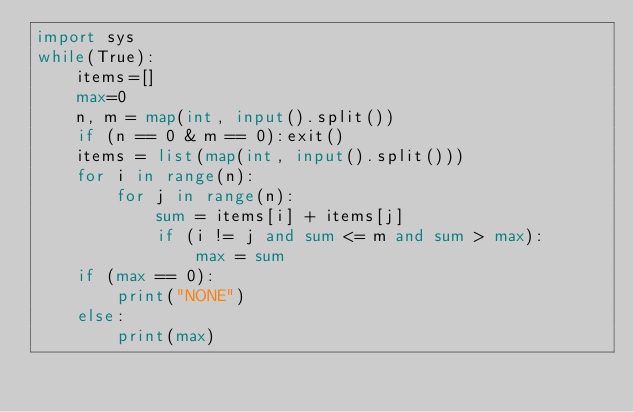<code> <loc_0><loc_0><loc_500><loc_500><_Python_>import sys
while(True):
    items=[]
    max=0
    n, m = map(int, input().split())
    if (n == 0 & m == 0):exit()
    items = list(map(int, input().split()))
    for i in range(n):
        for j in range(n):
            sum = items[i] + items[j]
            if (i != j and sum <= m and sum > max):
                max = sum
    if (max == 0):
        print("NONE")
    else:
        print(max)

</code> 